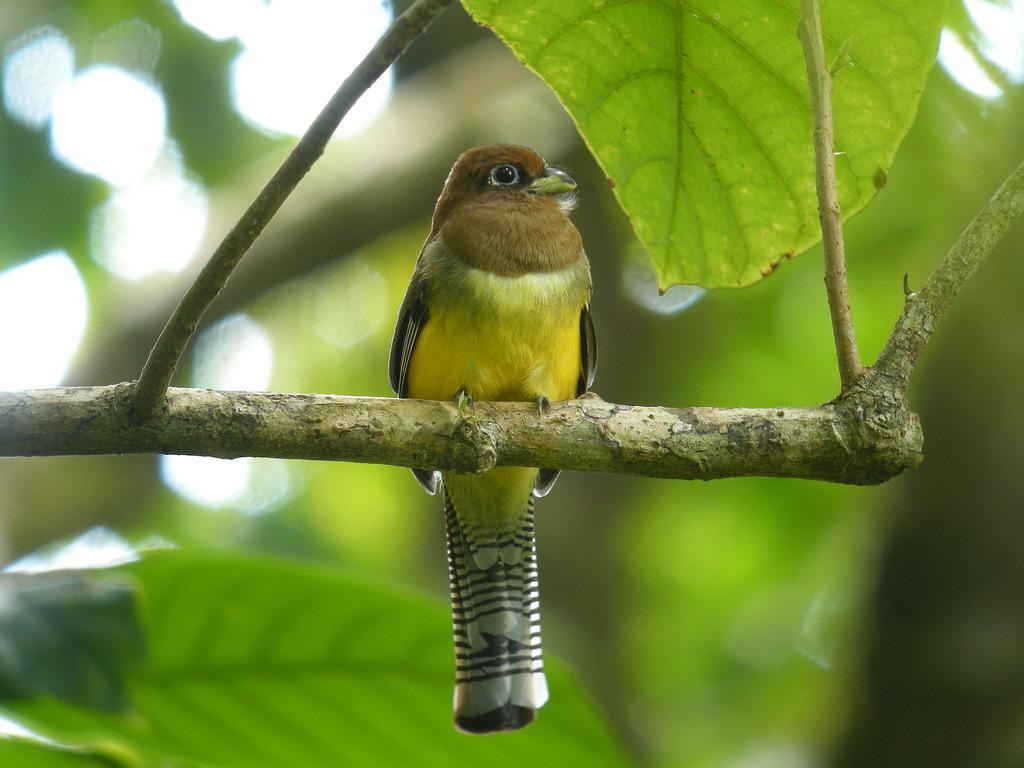In one or two sentences, can you explain what this image depicts? This image consists of a bird sitting on a stem. In the background, there are green leaves. 